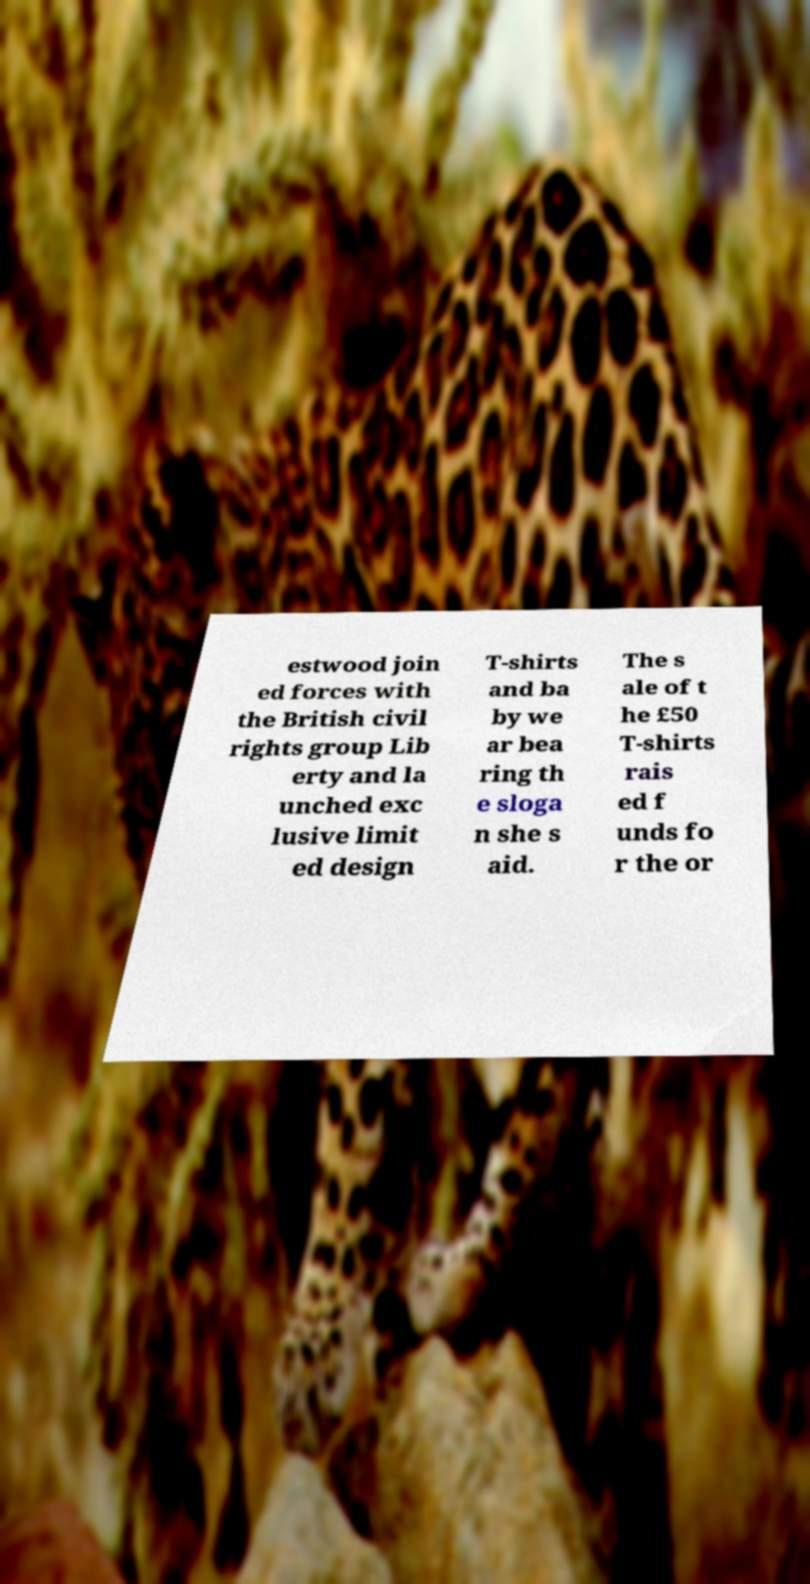Could you assist in decoding the text presented in this image and type it out clearly? estwood join ed forces with the British civil rights group Lib erty and la unched exc lusive limit ed design T-shirts and ba by we ar bea ring th e sloga n she s aid. The s ale of t he £50 T-shirts rais ed f unds fo r the or 